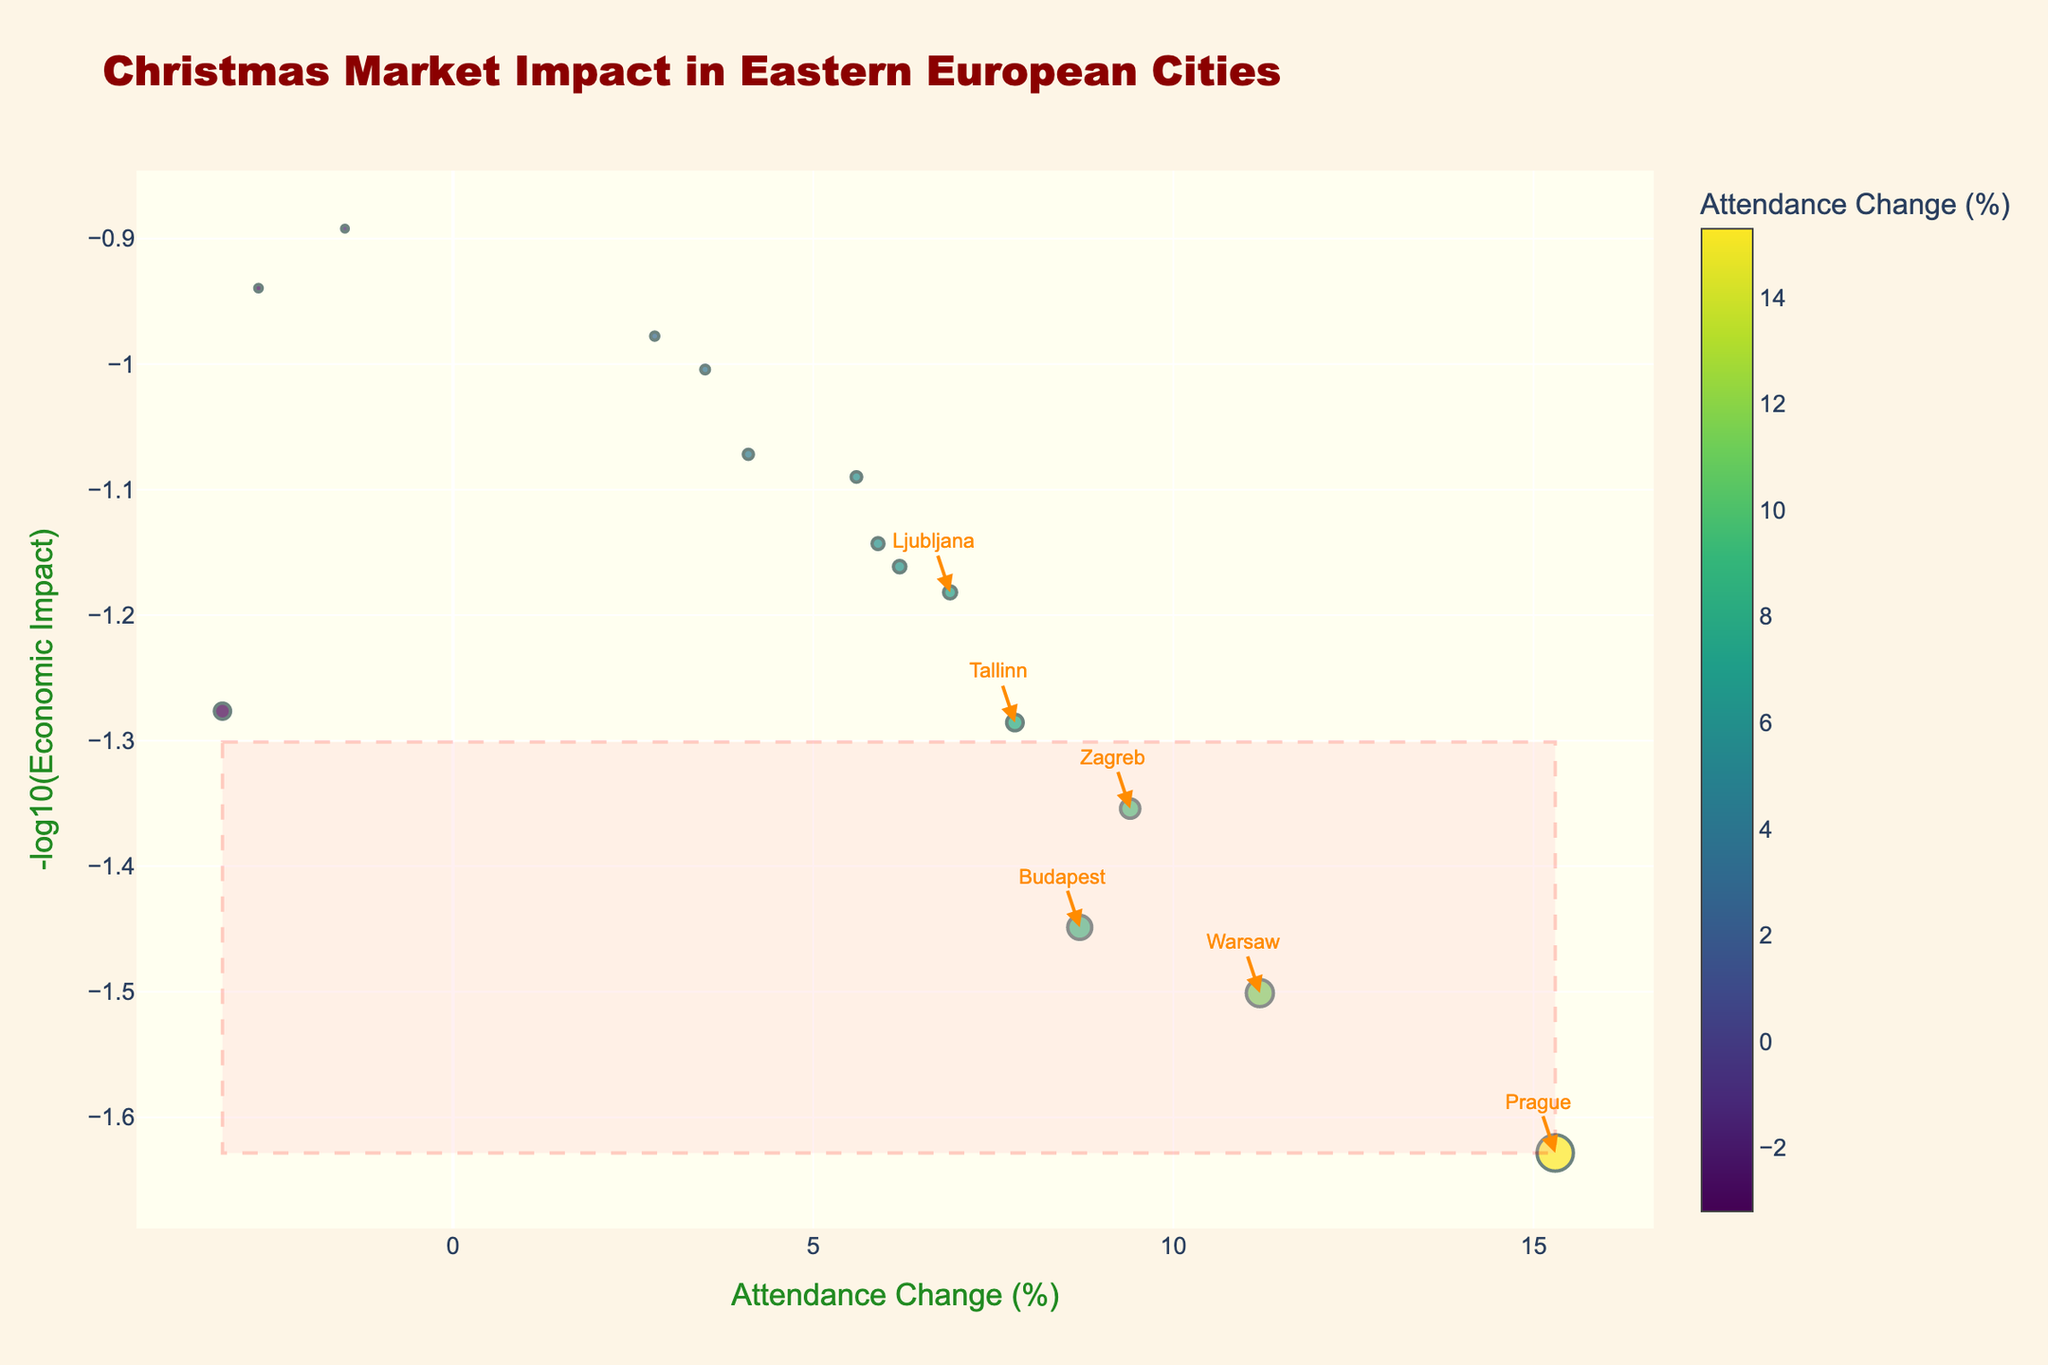What is the title of the plot? The title is located at the top of the plot and it states the main subject of the visualization.
Answer: Christmas Market Impact in Eastern European Cities Which city had the highest attendance change percentage? The plot shows different attendance changes for each city, color-coded on the x-axis. To find the city with the highest attendance change, look for the highest point on the x-axis.
Answer: Prague How many cities show significant economic impact? Significant cities are highlighted with annotations on the plot. Count the number of annotated city names.
Answer: 7 Which city has the least economic impact among those that show significant impact? Only consider cities that are annotated in the plot. Compare their positions on the y-axis, which represents the negative log of economic impact. The city closest to the bottom has the lowest economic impact.
Answer: Ljubljana Is there a city with an economic impact of around 10 million EUR but a negative attendance change? Examine the non-significant cities for this criterion. Look for points in the negative attendance range on the x-axis around the economic impact value of 10 on the plot.
Answer: Gdansk Which significant city had the lowest attendance change? Among the annotated cities, find the one with the lowest value on the x-axis, representing attendance change.
Answer: Ljubljana Compare the economic impact of Warsaw and Budapest. Which one is higher? Locate both cities on the plot and compare their economic impacts based on their positions on the y-axis. The lower the point on the y-axis, the higher the economic impact.
Answer: Warsaw Which city has the largest marker size on the plot? Marker size represents the economic impact, so look for the largest marker.
Answer: Prague 